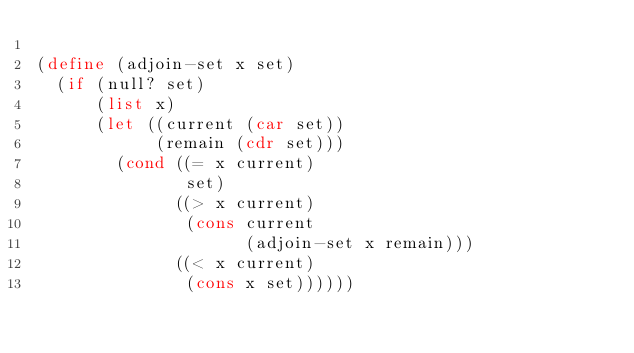<code> <loc_0><loc_0><loc_500><loc_500><_Scheme_>
(define (adjoin-set x set)
  (if (null? set)
      (list x)
      (let ((current (car set))
            (remain (cdr set)))
        (cond ((= x current)
               set)
              ((> x current)
               (cons current
                     (adjoin-set x remain)))
              ((< x current)
               (cons x set))))))</code> 